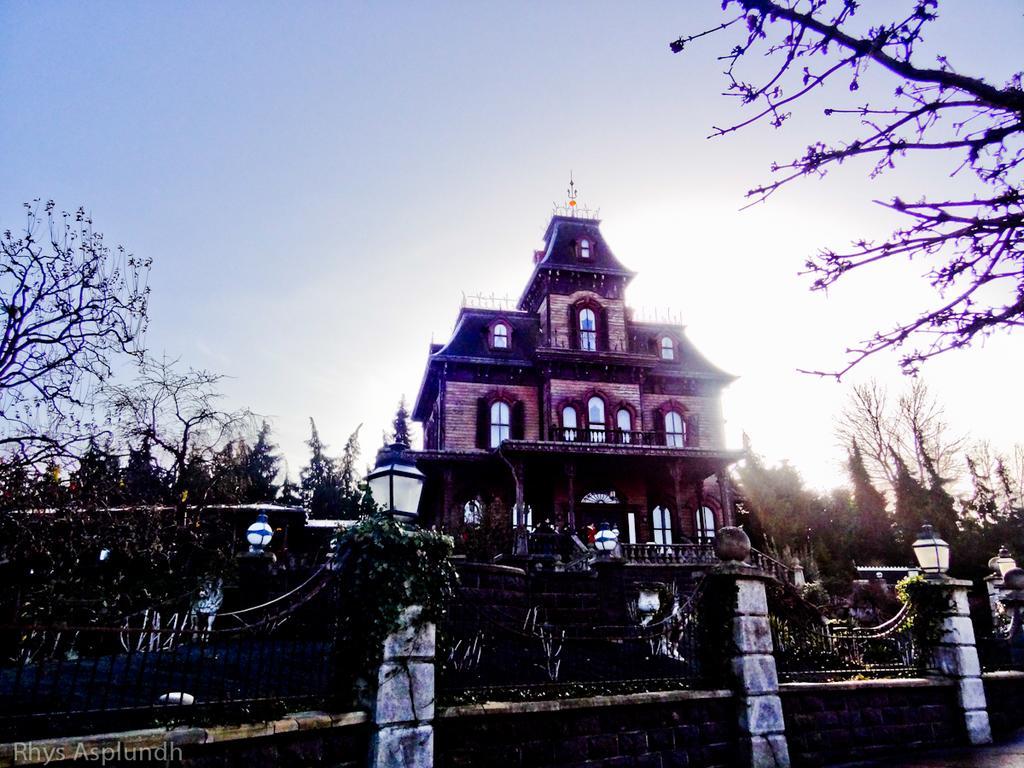Can you describe this image briefly? In this image I can see a rail. On the left and right side, I can see the trees. In the background, I can see a house and the sky. 